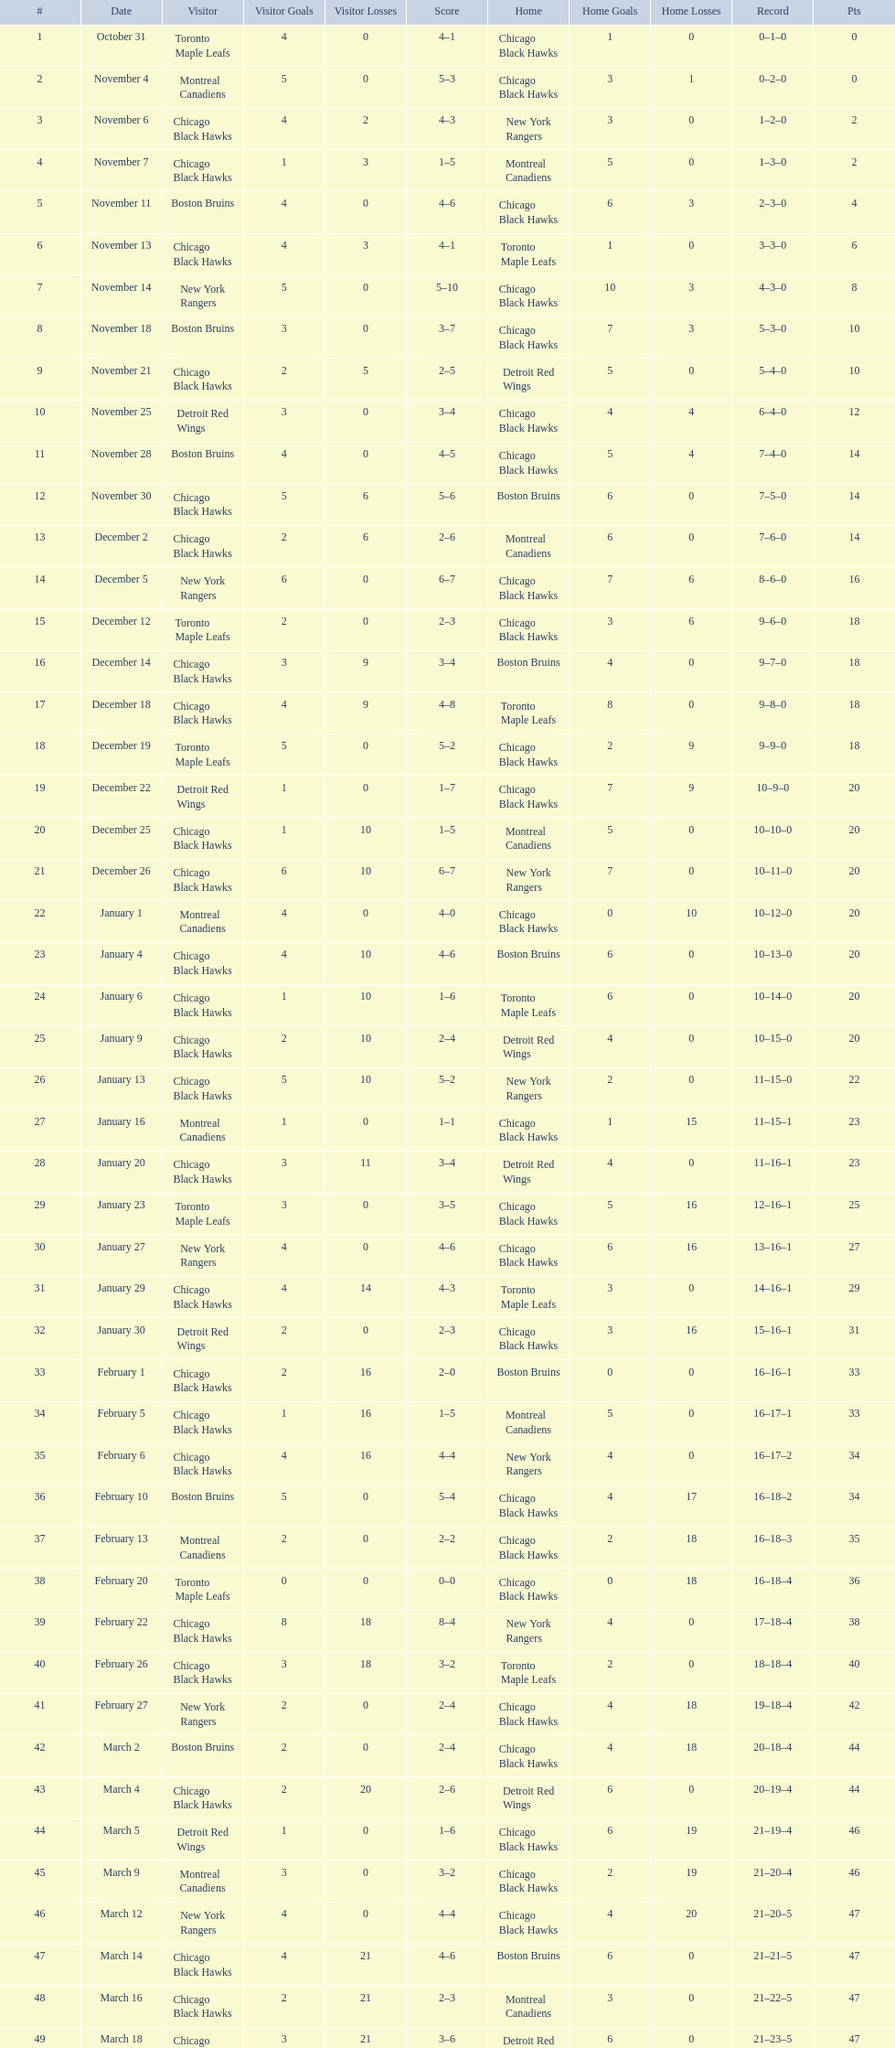Were the chicago blackhawks or the boston bruins the home team on december 14? Boston Bruins. 